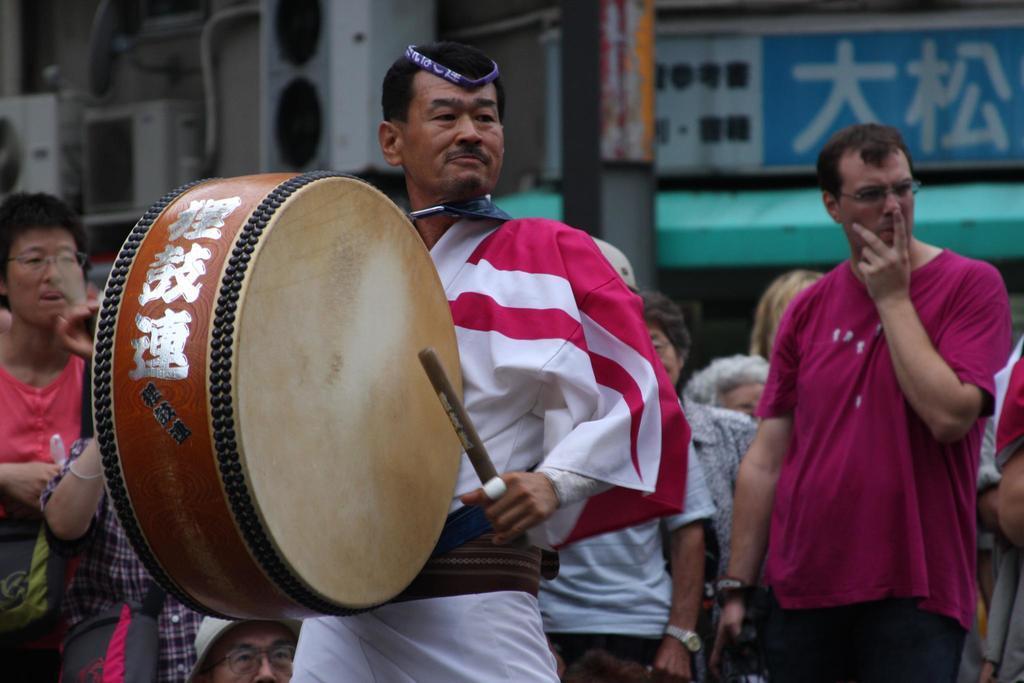Could you give a brief overview of what you see in this image? On the background we can see hoarding and a pole. We can see a man in front of the picture holding stick in his hand and playing drums. We can see all the persons standing. 